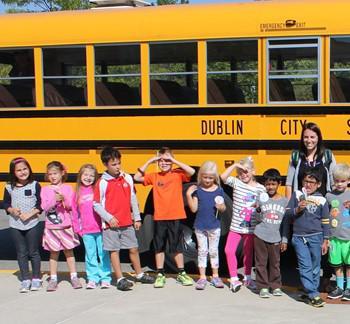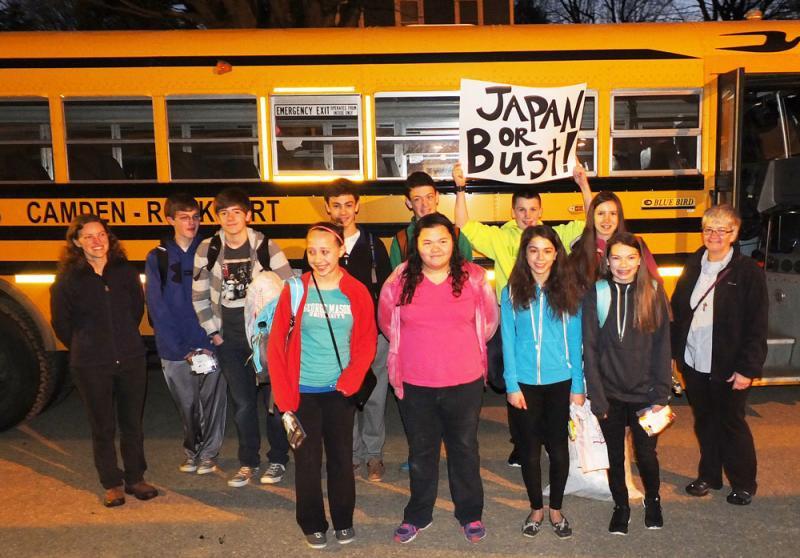The first image is the image on the left, the second image is the image on the right. For the images displayed, is the sentence "Each image shows children facing the camera and standing side-by-side in at least one horizontal line in front of the entry-door side of the bus." factually correct? Answer yes or no. Yes. The first image is the image on the left, the second image is the image on the right. Given the left and right images, does the statement "In the left image there is a group of kids standing in front of a school bus, and the front end of the bus is visible." hold true? Answer yes or no. No. 